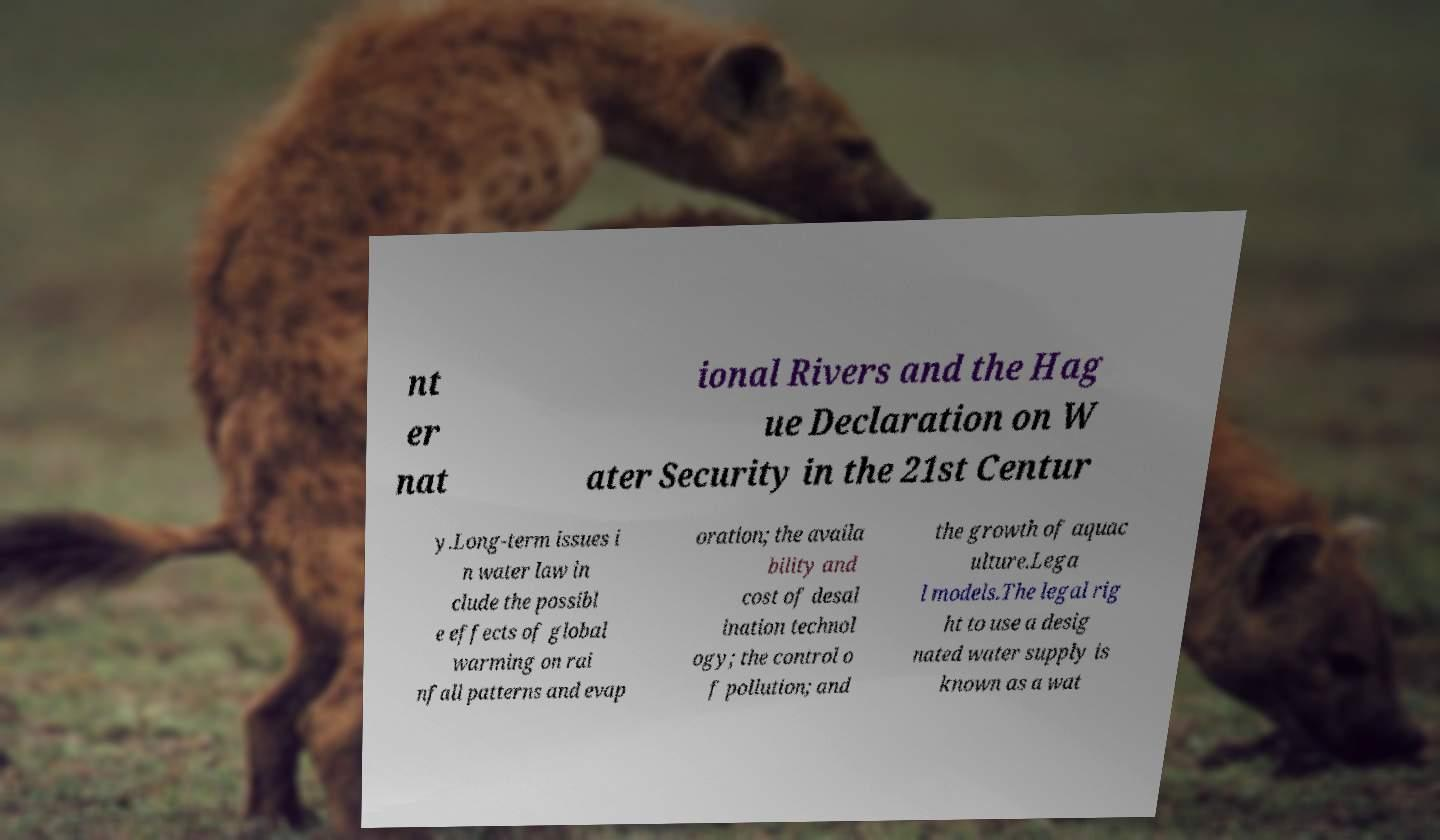Can you read and provide the text displayed in the image?This photo seems to have some interesting text. Can you extract and type it out for me? nt er nat ional Rivers and the Hag ue Declaration on W ater Security in the 21st Centur y.Long-term issues i n water law in clude the possibl e effects of global warming on rai nfall patterns and evap oration; the availa bility and cost of desal ination technol ogy; the control o f pollution; and the growth of aquac ulture.Lega l models.The legal rig ht to use a desig nated water supply is known as a wat 